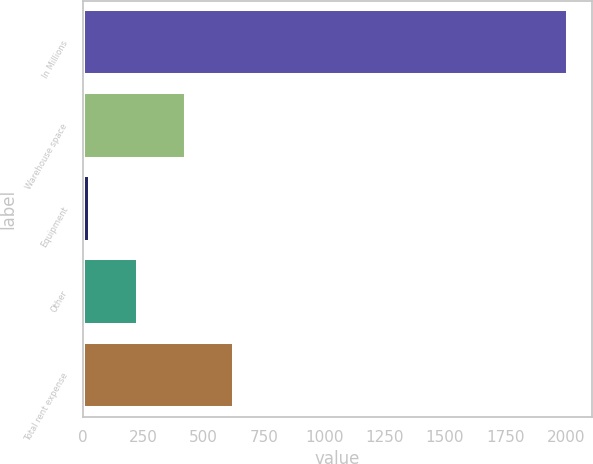Convert chart. <chart><loc_0><loc_0><loc_500><loc_500><bar_chart><fcel>In Millions<fcel>Warehouse space<fcel>Equipment<fcel>Other<fcel>Total rent expense<nl><fcel>2010<fcel>426.48<fcel>30.6<fcel>228.54<fcel>624.42<nl></chart> 